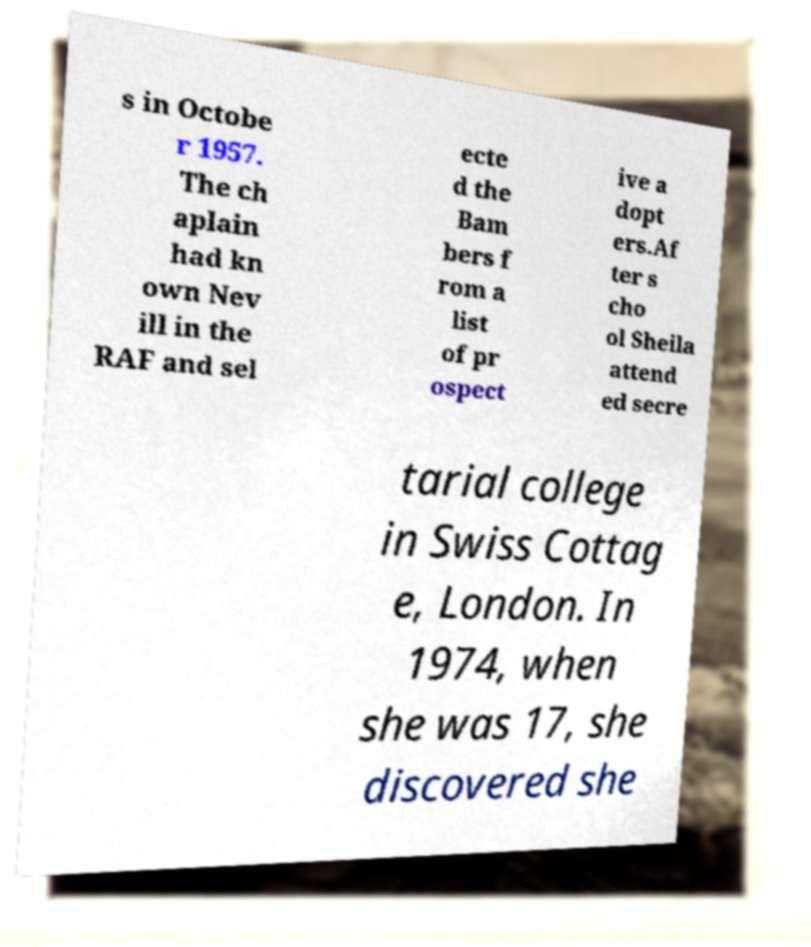Could you assist in decoding the text presented in this image and type it out clearly? s in Octobe r 1957. The ch aplain had kn own Nev ill in the RAF and sel ecte d the Bam bers f rom a list of pr ospect ive a dopt ers.Af ter s cho ol Sheila attend ed secre tarial college in Swiss Cottag e, London. In 1974, when she was 17, she discovered she 